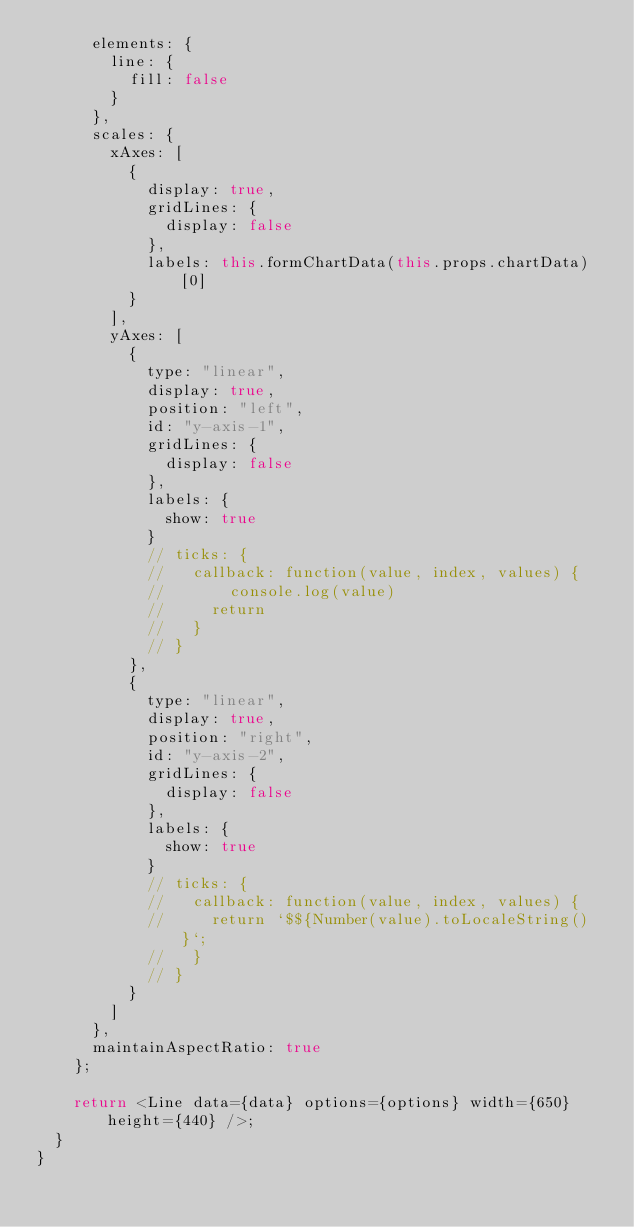<code> <loc_0><loc_0><loc_500><loc_500><_JavaScript_>      elements: {
        line: {
          fill: false
        }
      },
      scales: {
        xAxes: [
          {
            display: true,
            gridLines: {
              display: false
            },
            labels: this.formChartData(this.props.chartData)[0]
          }
        ],
        yAxes: [
          {
            type: "linear",
            display: true,
            position: "left",
            id: "y-axis-1",
            gridLines: {
              display: false
            },
            labels: {
              show: true
            }
            // ticks: {
            //   callback: function(value, index, values) {
            //       console.log(value)
            //     return
            //   }
            // }
          },
          {
            type: "linear",
            display: true,
            position: "right",
            id: "y-axis-2",
            gridLines: {
              display: false
            },
            labels: {
              show: true
            }
            // ticks: {
            //   callback: function(value, index, values) {
            //     return `$${Number(value).toLocaleString()}`;
            //   }
            // }
          }
        ]
      },
      maintainAspectRatio: true
    };

    return <Line data={data} options={options} width={650} height={440} />;
  }
}
</code> 